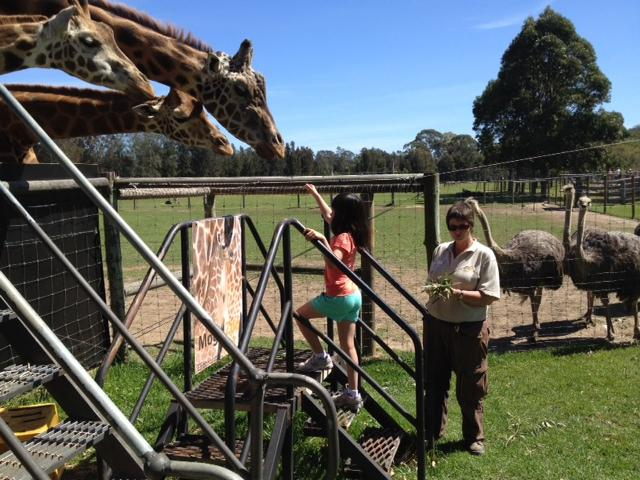Why is the short haired woman wearing a khaki shirt? Please explain your reasoning. dress code. This looks like she works in a zoo of some sort and this is part of the staffs unirform. 